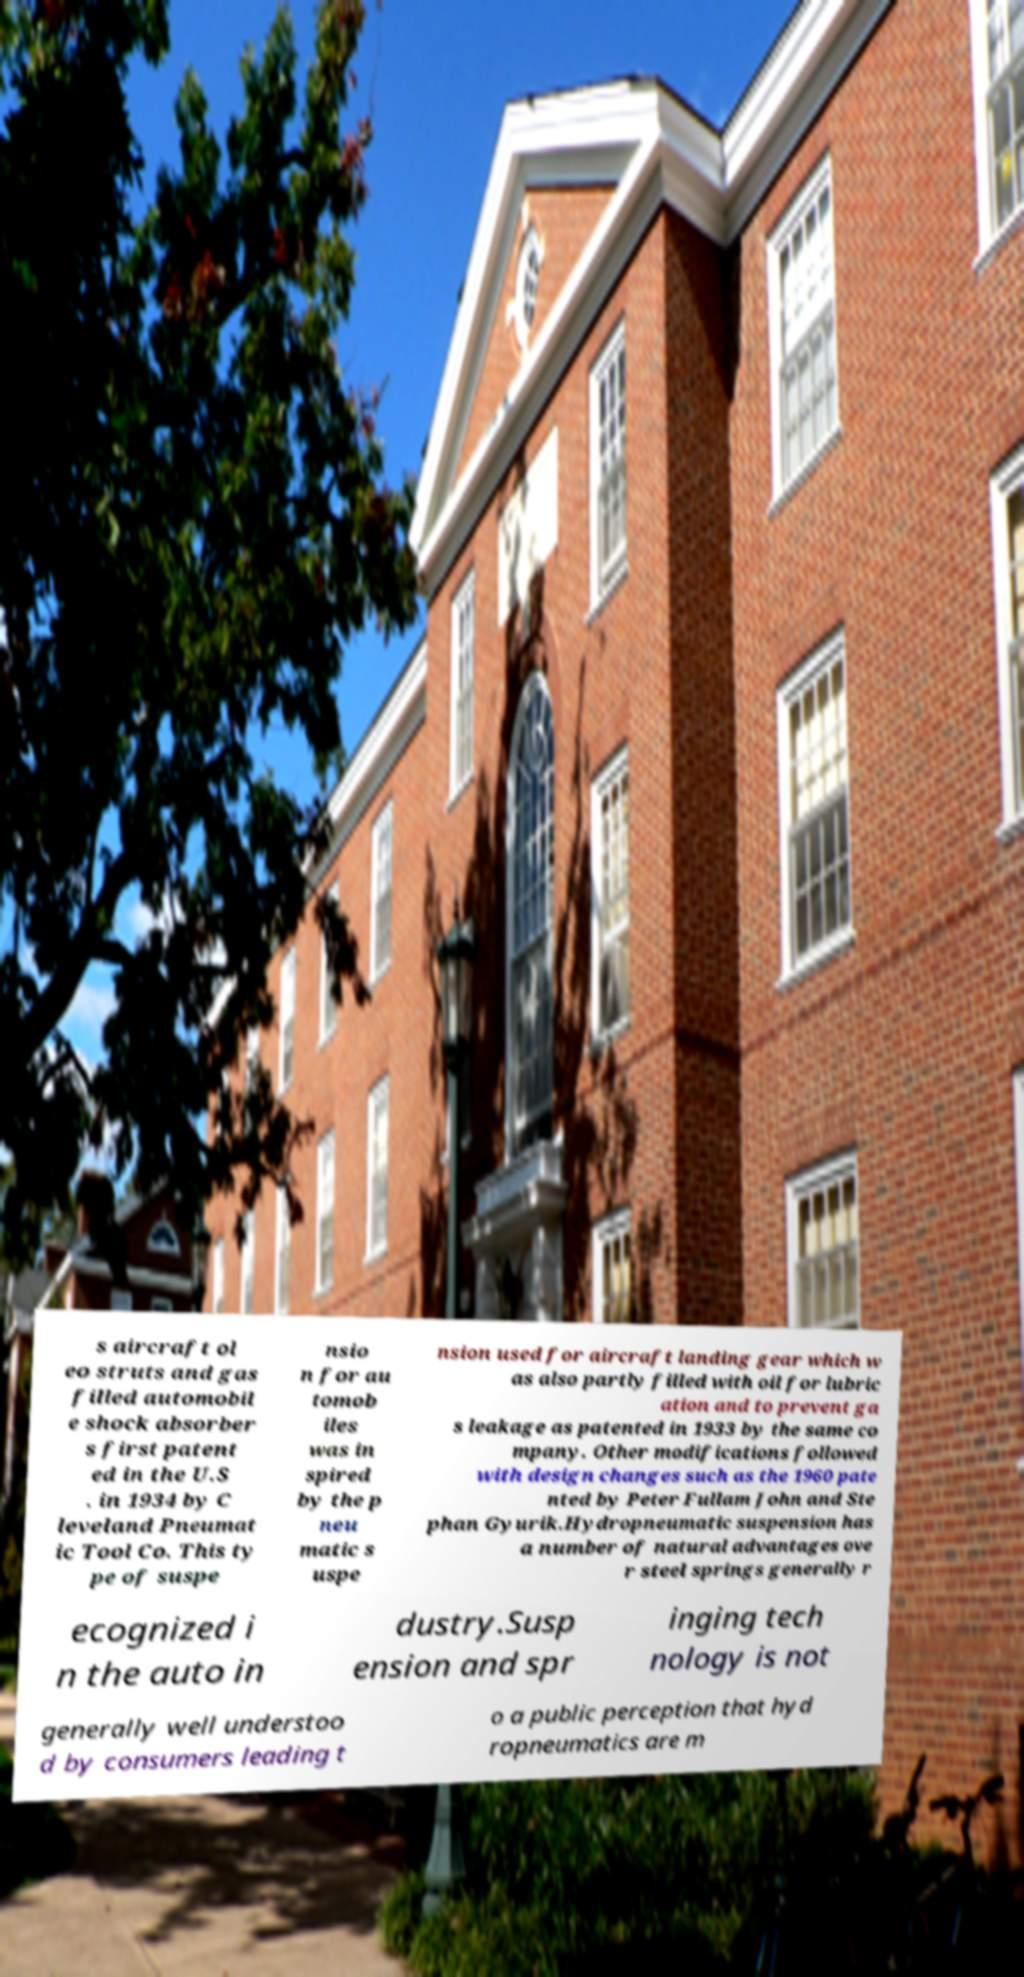What messages or text are displayed in this image? I need them in a readable, typed format. s aircraft ol eo struts and gas filled automobil e shock absorber s first patent ed in the U.S . in 1934 by C leveland Pneumat ic Tool Co. This ty pe of suspe nsio n for au tomob iles was in spired by the p neu matic s uspe nsion used for aircraft landing gear which w as also partly filled with oil for lubric ation and to prevent ga s leakage as patented in 1933 by the same co mpany. Other modifications followed with design changes such as the 1960 pate nted by Peter Fullam John and Ste phan Gyurik.Hydropneumatic suspension has a number of natural advantages ove r steel springs generally r ecognized i n the auto in dustry.Susp ension and spr inging tech nology is not generally well understoo d by consumers leading t o a public perception that hyd ropneumatics are m 